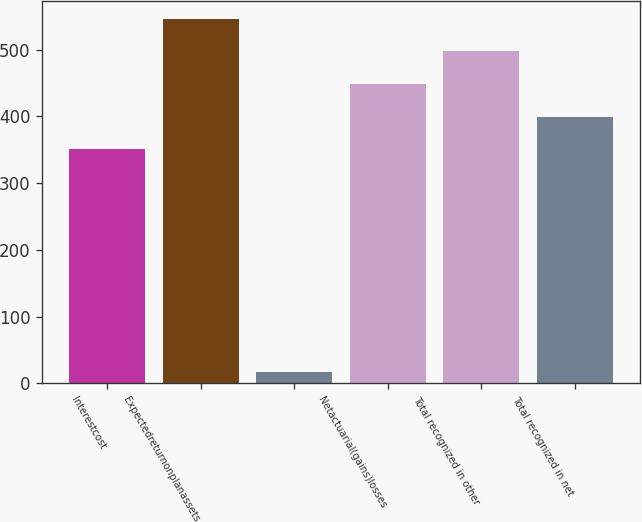Convert chart. <chart><loc_0><loc_0><loc_500><loc_500><bar_chart><fcel>Interestcost<fcel>Expectedreturnonplanassets<fcel>Unnamed: 2<fcel>Netactuarial(gains)losses<fcel>Total recognized in other<fcel>Total recognized in net<nl><fcel>351<fcel>546.2<fcel>17<fcel>448.6<fcel>497.4<fcel>399.8<nl></chart> 